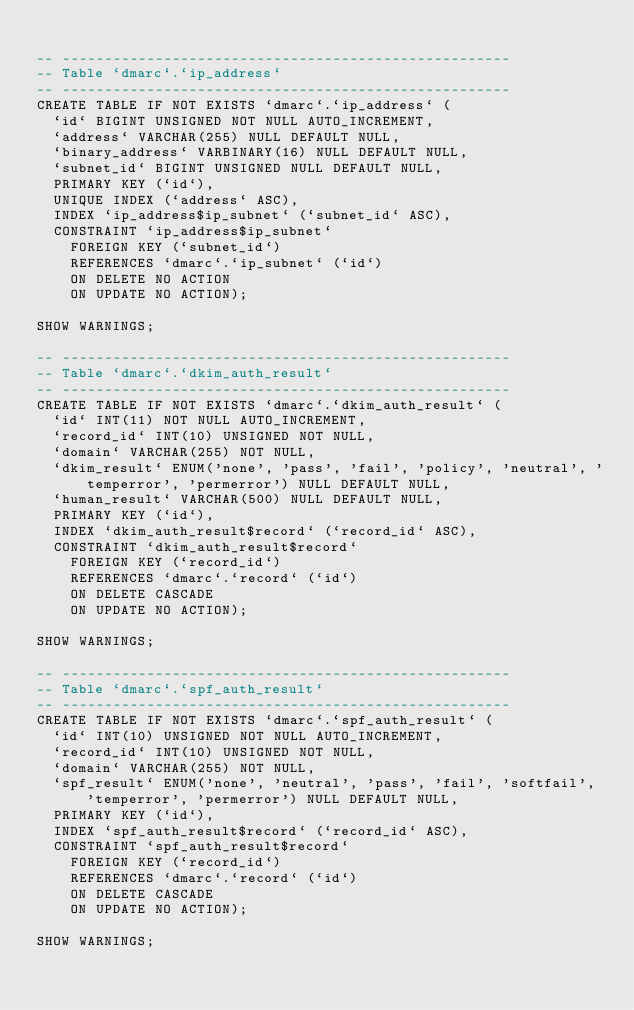Convert code to text. <code><loc_0><loc_0><loc_500><loc_500><_SQL_>
-- -----------------------------------------------------
-- Table `dmarc`.`ip_address`
-- -----------------------------------------------------
CREATE TABLE IF NOT EXISTS `dmarc`.`ip_address` (
  `id` BIGINT UNSIGNED NOT NULL AUTO_INCREMENT,
  `address` VARCHAR(255) NULL DEFAULT NULL,
  `binary_address` VARBINARY(16) NULL DEFAULT NULL,
  `subnet_id` BIGINT UNSIGNED NULL DEFAULT NULL,
  PRIMARY KEY (`id`),
  UNIQUE INDEX (`address` ASC),
  INDEX `ip_address$ip_subnet` (`subnet_id` ASC),
  CONSTRAINT `ip_address$ip_subnet`
    FOREIGN KEY (`subnet_id`)
    REFERENCES `dmarc`.`ip_subnet` (`id`)
    ON DELETE NO ACTION
    ON UPDATE NO ACTION);

SHOW WARNINGS;

-- -----------------------------------------------------
-- Table `dmarc`.`dkim_auth_result`
-- -----------------------------------------------------
CREATE TABLE IF NOT EXISTS `dmarc`.`dkim_auth_result` (
  `id` INT(11) NOT NULL AUTO_INCREMENT,
  `record_id` INT(10) UNSIGNED NOT NULL,
  `domain` VARCHAR(255) NOT NULL,
  `dkim_result` ENUM('none', 'pass', 'fail', 'policy', 'neutral', 'temperror', 'permerror') NULL DEFAULT NULL,
  `human_result` VARCHAR(500) NULL DEFAULT NULL,
  PRIMARY KEY (`id`),
  INDEX `dkim_auth_result$record` (`record_id` ASC),
  CONSTRAINT `dkim_auth_result$record`
    FOREIGN KEY (`record_id`)
    REFERENCES `dmarc`.`record` (`id`)
    ON DELETE CASCADE
    ON UPDATE NO ACTION);

SHOW WARNINGS;

-- -----------------------------------------------------
-- Table `dmarc`.`spf_auth_result`
-- -----------------------------------------------------
CREATE TABLE IF NOT EXISTS `dmarc`.`spf_auth_result` (
  `id` INT(10) UNSIGNED NOT NULL AUTO_INCREMENT,
  `record_id` INT(10) UNSIGNED NOT NULL,
  `domain` VARCHAR(255) NOT NULL,
  `spf_result` ENUM('none', 'neutral', 'pass', 'fail', 'softfail', 'temperror', 'permerror') NULL DEFAULT NULL,
  PRIMARY KEY (`id`),
  INDEX `spf_auth_result$record` (`record_id` ASC),
  CONSTRAINT `spf_auth_result$record`
    FOREIGN KEY (`record_id`)
    REFERENCES `dmarc`.`record` (`id`)
    ON DELETE CASCADE
    ON UPDATE NO ACTION);

SHOW WARNINGS;
</code> 